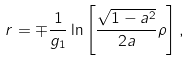Convert formula to latex. <formula><loc_0><loc_0><loc_500><loc_500>r = \mp \frac { 1 } { g _ { 1 } } \ln \left [ \frac { \sqrt { 1 - a ^ { 2 } } } { 2 a } \rho \right ] ,</formula> 